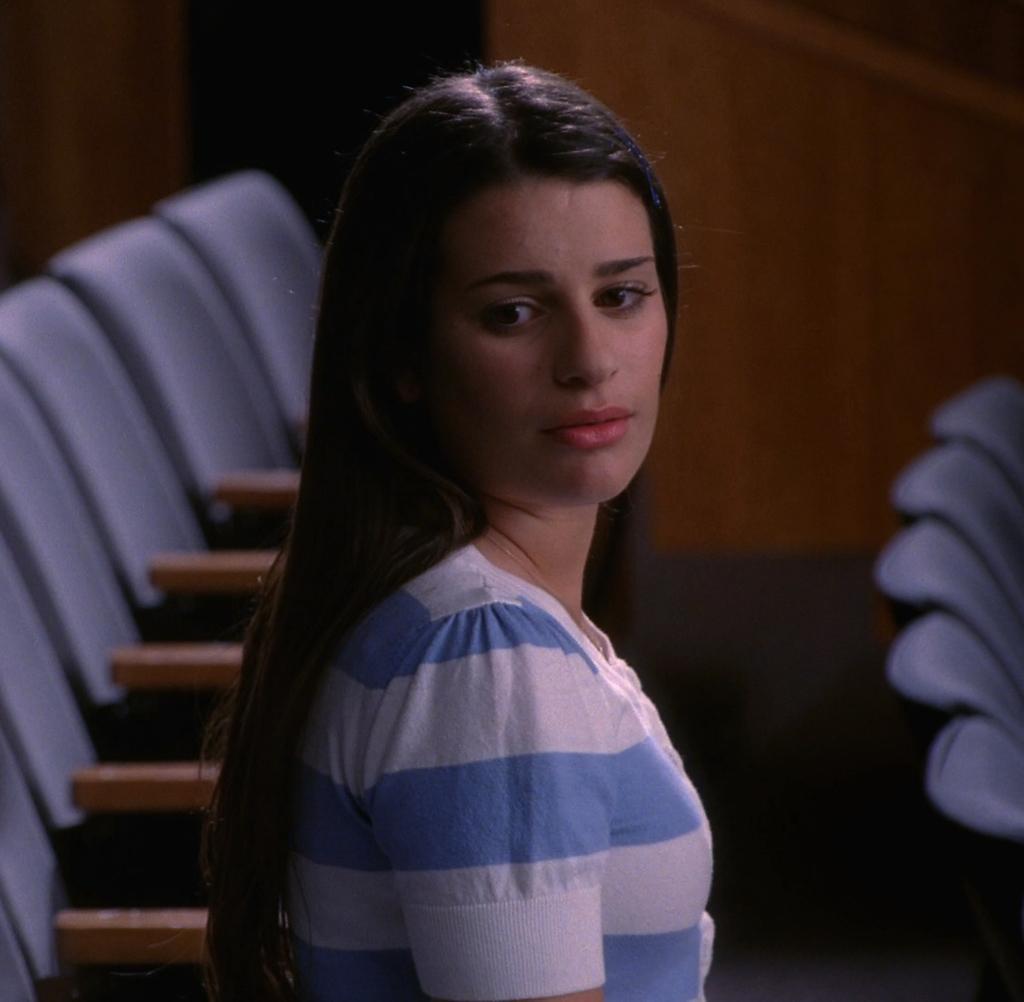How would you summarize this image in a sentence or two? In this image we can see a woman sitting on the chair. In the background we can see empty chairs. 